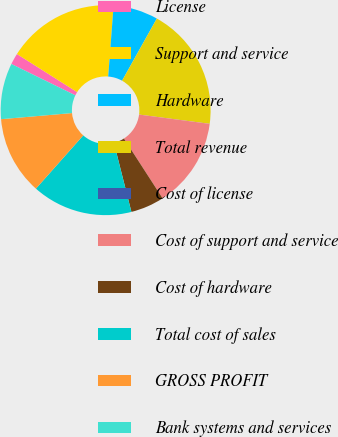Convert chart. <chart><loc_0><loc_0><loc_500><loc_500><pie_chart><fcel>License<fcel>Support and service<fcel>Hardware<fcel>Total revenue<fcel>Cost of license<fcel>Cost of support and service<fcel>Cost of hardware<fcel>Total cost of sales<fcel>GROSS PROFIT<fcel>Bank systems and services<nl><fcel>1.73%<fcel>17.23%<fcel>6.9%<fcel>18.96%<fcel>0.01%<fcel>13.79%<fcel>5.18%<fcel>15.51%<fcel>12.07%<fcel>8.62%<nl></chart> 